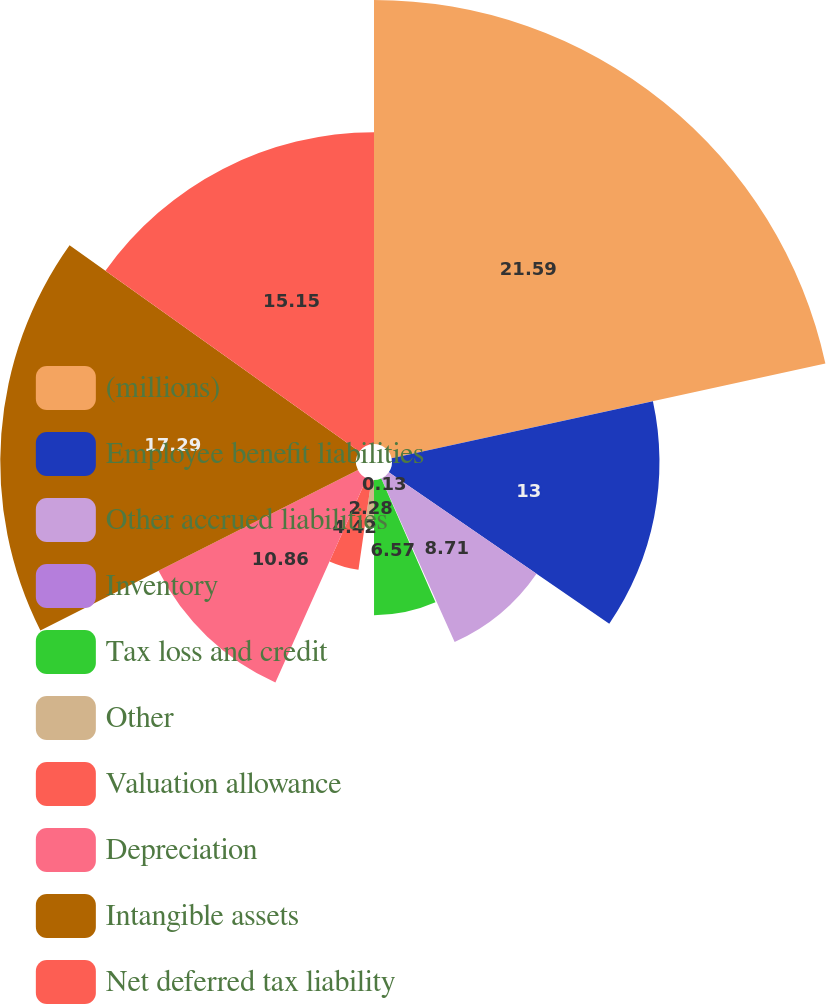Convert chart to OTSL. <chart><loc_0><loc_0><loc_500><loc_500><pie_chart><fcel>(millions)<fcel>Employee benefit liabilities<fcel>Other accrued liabilities<fcel>Inventory<fcel>Tax loss and credit<fcel>Other<fcel>Valuation allowance<fcel>Depreciation<fcel>Intangible assets<fcel>Net deferred tax liability<nl><fcel>21.58%<fcel>13.0%<fcel>8.71%<fcel>0.13%<fcel>6.57%<fcel>2.28%<fcel>4.42%<fcel>10.86%<fcel>17.29%<fcel>15.15%<nl></chart> 